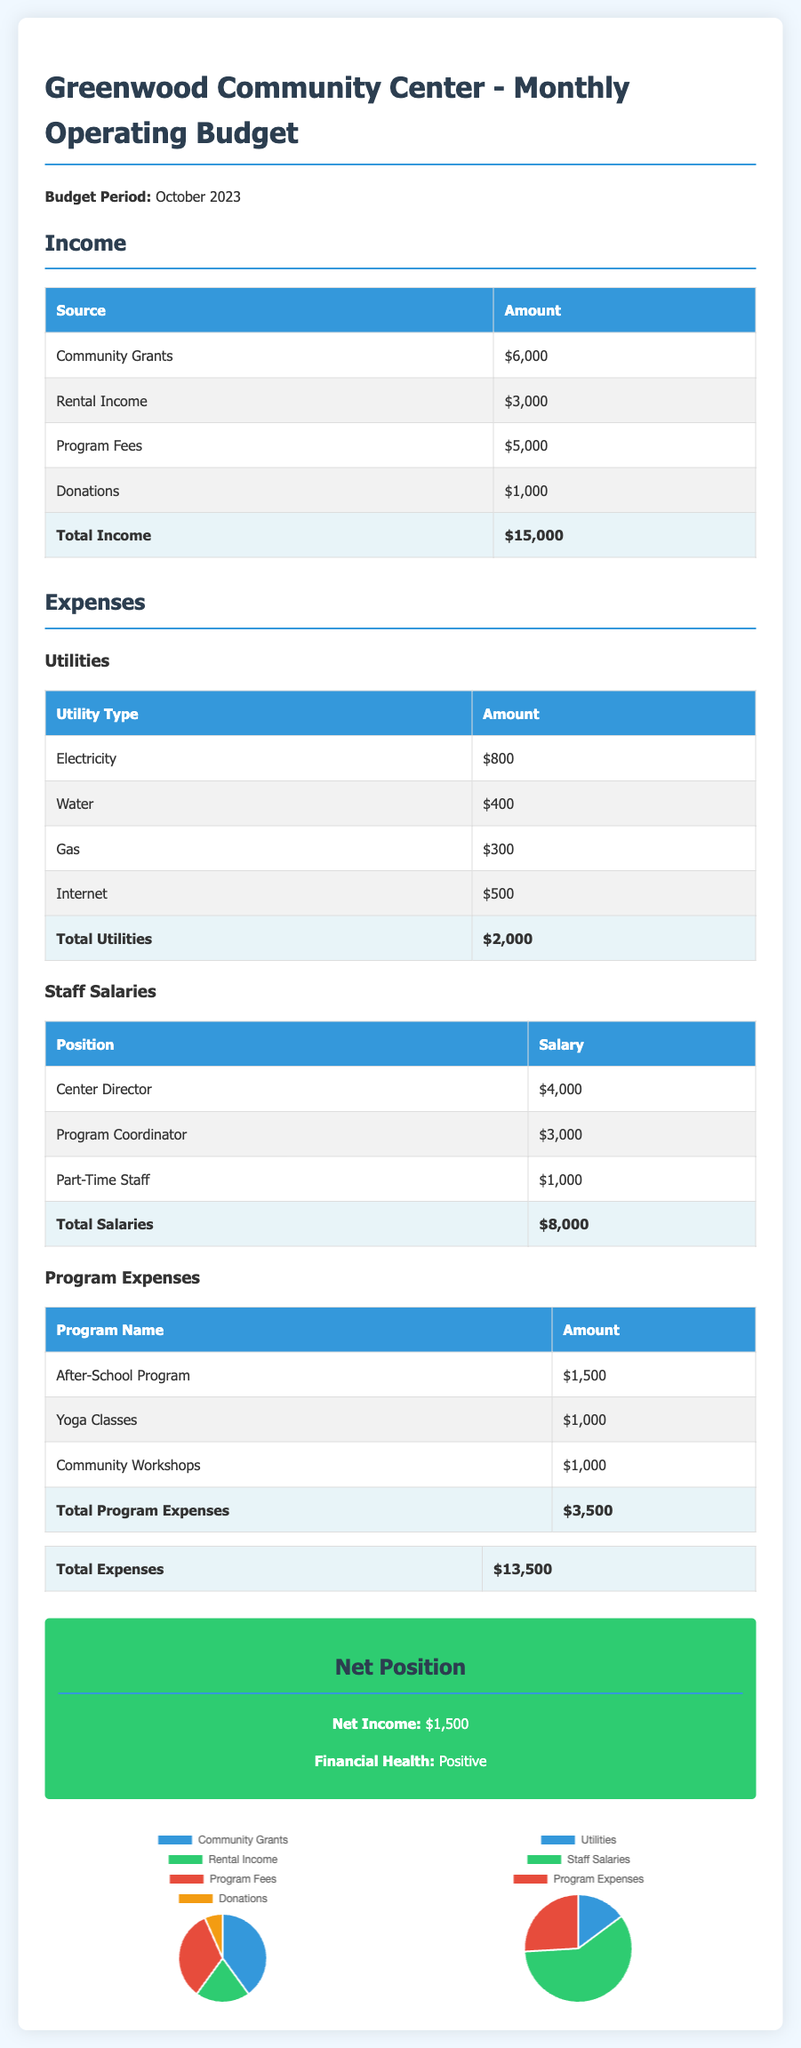What is the total income? The total income is found by adding all income sources listed in the budget, which are $6,000 + $3,000 + $5,000 + $1,000.
Answer: $15,000 What is the total amount spent on utilities? The total utilities amount is calculated by adding the individual utility costs, which are $800 + $400 + $300 + $500.
Answer: $2,000 What are the total salaries for staff? The total salaries can be obtained by summing the salaries of all staff positions, which are $4,000 + $3,000 + $1,000.
Answer: $8,000 How much is allocated for program expenses? The total program expenses can be determined by adding the costs of all listed programs, which are $1,500 + $1,000 + $1,000.
Answer: $3,500 What is the net income for the month? The net income is calculated by subtracting total expenses from total income, which is $15,000 - $13,500.
Answer: $1,500 What is the financial health status according to the document? The financial health status is stated in the document based on net income being positive.
Answer: Positive Which expense category has the largest amount? By comparing the expense categories (Utilities, Staff Salaries, Program Expenses), Staff Salaries has the largest amount listed at $8,000.
Answer: Staff Salaries How much was received from community grants? The document lists community grants as a source of income, with a specific amount.
Answer: $6,000 What is the amount spent on the After-School Program? The After-School Program is specified in the program expenses section with its individual amount listed.
Answer: $1,500 